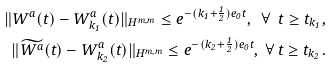Convert formula to latex. <formula><loc_0><loc_0><loc_500><loc_500>\| W ^ { a } ( t ) - W _ { k _ { 1 } } ^ { a } ( t ) \| _ { H ^ { m , m } } \leq e ^ { - ( k _ { 1 } + \frac { 1 } { 2 } ) e _ { 0 } t } , \ \forall \ t \geq t _ { k _ { 1 } } , \\ \| \widetilde { W ^ { a } } ( t ) - W _ { k _ { 2 } } ^ { a } ( t ) \| _ { H ^ { m , m } } \leq e ^ { - ( k _ { 2 } + \frac { 1 } { 2 } ) e _ { 0 } t } , \ \forall \ t \geq t _ { k _ { 2 } } .</formula> 